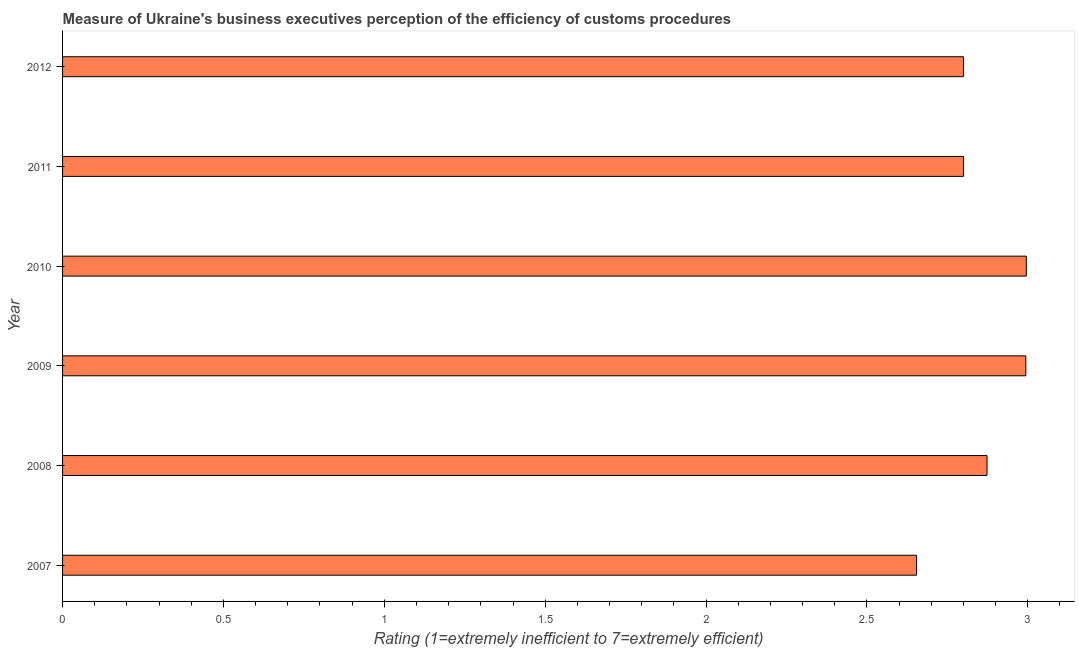Does the graph contain any zero values?
Keep it short and to the point. No. What is the title of the graph?
Give a very brief answer. Measure of Ukraine's business executives perception of the efficiency of customs procedures. What is the label or title of the X-axis?
Keep it short and to the point. Rating (1=extremely inefficient to 7=extremely efficient). What is the label or title of the Y-axis?
Keep it short and to the point. Year. What is the rating measuring burden of customs procedure in 2007?
Ensure brevity in your answer.  2.65. Across all years, what is the maximum rating measuring burden of customs procedure?
Provide a short and direct response. 3. Across all years, what is the minimum rating measuring burden of customs procedure?
Offer a very short reply. 2.65. In which year was the rating measuring burden of customs procedure minimum?
Provide a succinct answer. 2007. What is the sum of the rating measuring burden of customs procedure?
Offer a very short reply. 17.12. What is the difference between the rating measuring burden of customs procedure in 2007 and 2010?
Provide a short and direct response. -0.34. What is the average rating measuring burden of customs procedure per year?
Your answer should be very brief. 2.85. What is the median rating measuring burden of customs procedure?
Provide a short and direct response. 2.84. In how many years, is the rating measuring burden of customs procedure greater than 0.7 ?
Give a very brief answer. 6. Do a majority of the years between 2008 and 2009 (inclusive) have rating measuring burden of customs procedure greater than 2.1 ?
Your response must be concise. Yes. What is the ratio of the rating measuring burden of customs procedure in 2007 to that in 2012?
Your answer should be very brief. 0.95. Is the rating measuring burden of customs procedure in 2011 less than that in 2012?
Ensure brevity in your answer.  No. Is the difference between the rating measuring burden of customs procedure in 2011 and 2012 greater than the difference between any two years?
Ensure brevity in your answer.  No. What is the difference between the highest and the second highest rating measuring burden of customs procedure?
Your response must be concise. 0. Is the sum of the rating measuring burden of customs procedure in 2009 and 2012 greater than the maximum rating measuring burden of customs procedure across all years?
Provide a short and direct response. Yes. What is the difference between the highest and the lowest rating measuring burden of customs procedure?
Ensure brevity in your answer.  0.34. In how many years, is the rating measuring burden of customs procedure greater than the average rating measuring burden of customs procedure taken over all years?
Ensure brevity in your answer.  3. How many bars are there?
Keep it short and to the point. 6. Are all the bars in the graph horizontal?
Your answer should be very brief. Yes. How many years are there in the graph?
Offer a terse response. 6. What is the Rating (1=extremely inefficient to 7=extremely efficient) in 2007?
Your answer should be compact. 2.65. What is the Rating (1=extremely inefficient to 7=extremely efficient) of 2008?
Your answer should be very brief. 2.87. What is the Rating (1=extremely inefficient to 7=extremely efficient) of 2009?
Offer a terse response. 2.99. What is the Rating (1=extremely inefficient to 7=extremely efficient) of 2010?
Ensure brevity in your answer.  3. What is the Rating (1=extremely inefficient to 7=extremely efficient) in 2011?
Offer a very short reply. 2.8. What is the difference between the Rating (1=extremely inefficient to 7=extremely efficient) in 2007 and 2008?
Offer a very short reply. -0.22. What is the difference between the Rating (1=extremely inefficient to 7=extremely efficient) in 2007 and 2009?
Provide a short and direct response. -0.34. What is the difference between the Rating (1=extremely inefficient to 7=extremely efficient) in 2007 and 2010?
Provide a short and direct response. -0.34. What is the difference between the Rating (1=extremely inefficient to 7=extremely efficient) in 2007 and 2011?
Your answer should be compact. -0.15. What is the difference between the Rating (1=extremely inefficient to 7=extremely efficient) in 2007 and 2012?
Offer a very short reply. -0.15. What is the difference between the Rating (1=extremely inefficient to 7=extremely efficient) in 2008 and 2009?
Provide a succinct answer. -0.12. What is the difference between the Rating (1=extremely inefficient to 7=extremely efficient) in 2008 and 2010?
Your answer should be very brief. -0.12. What is the difference between the Rating (1=extremely inefficient to 7=extremely efficient) in 2008 and 2011?
Provide a succinct answer. 0.07. What is the difference between the Rating (1=extremely inefficient to 7=extremely efficient) in 2008 and 2012?
Keep it short and to the point. 0.07. What is the difference between the Rating (1=extremely inefficient to 7=extremely efficient) in 2009 and 2010?
Provide a short and direct response. -0. What is the difference between the Rating (1=extremely inefficient to 7=extremely efficient) in 2009 and 2011?
Offer a very short reply. 0.19. What is the difference between the Rating (1=extremely inefficient to 7=extremely efficient) in 2009 and 2012?
Offer a very short reply. 0.19. What is the difference between the Rating (1=extremely inefficient to 7=extremely efficient) in 2010 and 2011?
Keep it short and to the point. 0.2. What is the difference between the Rating (1=extremely inefficient to 7=extremely efficient) in 2010 and 2012?
Provide a short and direct response. 0.2. What is the ratio of the Rating (1=extremely inefficient to 7=extremely efficient) in 2007 to that in 2008?
Provide a short and direct response. 0.92. What is the ratio of the Rating (1=extremely inefficient to 7=extremely efficient) in 2007 to that in 2009?
Keep it short and to the point. 0.89. What is the ratio of the Rating (1=extremely inefficient to 7=extremely efficient) in 2007 to that in 2010?
Make the answer very short. 0.89. What is the ratio of the Rating (1=extremely inefficient to 7=extremely efficient) in 2007 to that in 2011?
Keep it short and to the point. 0.95. What is the ratio of the Rating (1=extremely inefficient to 7=extremely efficient) in 2007 to that in 2012?
Provide a succinct answer. 0.95. What is the ratio of the Rating (1=extremely inefficient to 7=extremely efficient) in 2008 to that in 2009?
Your answer should be compact. 0.96. What is the ratio of the Rating (1=extremely inefficient to 7=extremely efficient) in 2008 to that in 2010?
Give a very brief answer. 0.96. What is the ratio of the Rating (1=extremely inefficient to 7=extremely efficient) in 2008 to that in 2011?
Keep it short and to the point. 1.03. What is the ratio of the Rating (1=extremely inefficient to 7=extremely efficient) in 2009 to that in 2011?
Provide a short and direct response. 1.07. What is the ratio of the Rating (1=extremely inefficient to 7=extremely efficient) in 2009 to that in 2012?
Your answer should be very brief. 1.07. What is the ratio of the Rating (1=extremely inefficient to 7=extremely efficient) in 2010 to that in 2011?
Give a very brief answer. 1.07. What is the ratio of the Rating (1=extremely inefficient to 7=extremely efficient) in 2010 to that in 2012?
Offer a very short reply. 1.07. 